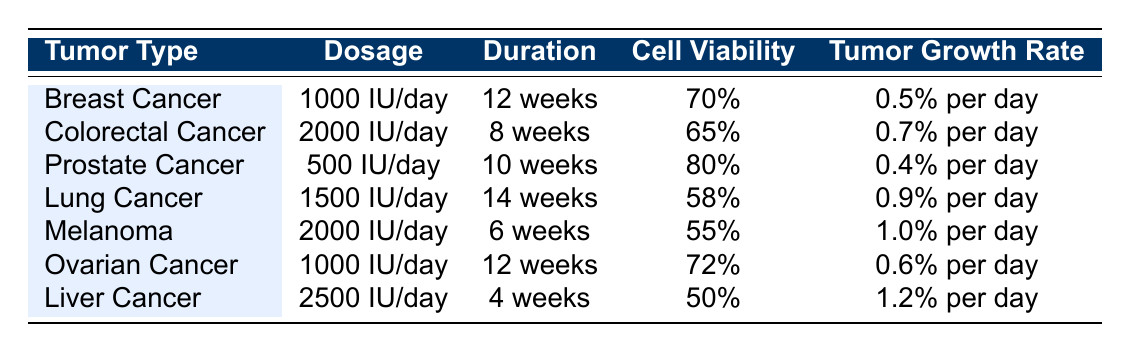What is the sample size for the study on Breast Cancer? The sample size for the Breast Cancer study (VD-001) is listed in the table under the 'sample size' column. According to the data provided, it is 50.
Answer: 50 What is the tumor growth rate for Colorectal Cancer? The tumor growth rate for Colorectal Cancer in the study (VD-002) can be found in the 'Tumor Growth Rate' column. The data states it is 0.7% per day.
Answer: 0.7% per day What is the dosage used in the study on Ovarian Cancer? The dosage for Ovarian Cancer study (VD-006) is specified in the 'Dosage' column of the table. The amount recorded is 1000 IU/day.
Answer: 1000 IU/day Which tumor type has the highest observed cell viability percentage? The cell viability percentages by tumor type must be compared. Prostate Cancer has 80%, while all others are less; hence, it has the highest observed cell viability percentage.
Answer: Prostate Cancer What is the total duration in weeks of the studies for Melanoma and Liver Cancer combined? The duration for Melanoma (VD-005) is 6 weeks, and for Liver Cancer (VD-007), it is 4 weeks. Summing these durations gives 6 + 4 = 10 weeks.
Answer: 10 weeks Is the cell viability for Lung Cancer greater than 60%? For Lung Cancer, the cell viability percentage is 58%, which is less than 60%. Therefore, the answer is no.
Answer: No What is the difference in tumor growth rates between Prostate Cancer and Breast Cancer? The tumor growth rate for Prostate Cancer is 0.4% per day, and for Breast Cancer, it is 0.5% per day. Subtracting these gives 0.5 - 0.4 = 0.1, indicating that Breast Cancer has a higher rate.
Answer: 0.1% per day Which tumor type has the lowest cell viability percentage? By looking at the cell viability percentages, Melanoma has the lowest at 55%. This can be confirmed by comparing all values in the 'Cell Viability' column.
Answer: Melanoma If we consider the studies for duration over 10 weeks, how many studies are there? The only studies that have a duration longer than 10 weeks are Lung Cancer (14 weeks) and Prostate Cancer (10 weeks, which does not count). Thus, there is only one study that exceeds 10 weeks duration.
Answer: 1 What percentage of the studies used a dosage of 2000 IU/day? There are a total of 7 studies, and 2 of them (Colorectal Cancer and Melanoma) used a dosage of 2000 IU/day. The percentage is calculated as (2/7) * 100 = 28.57%.
Answer: Approximately 28.57% 